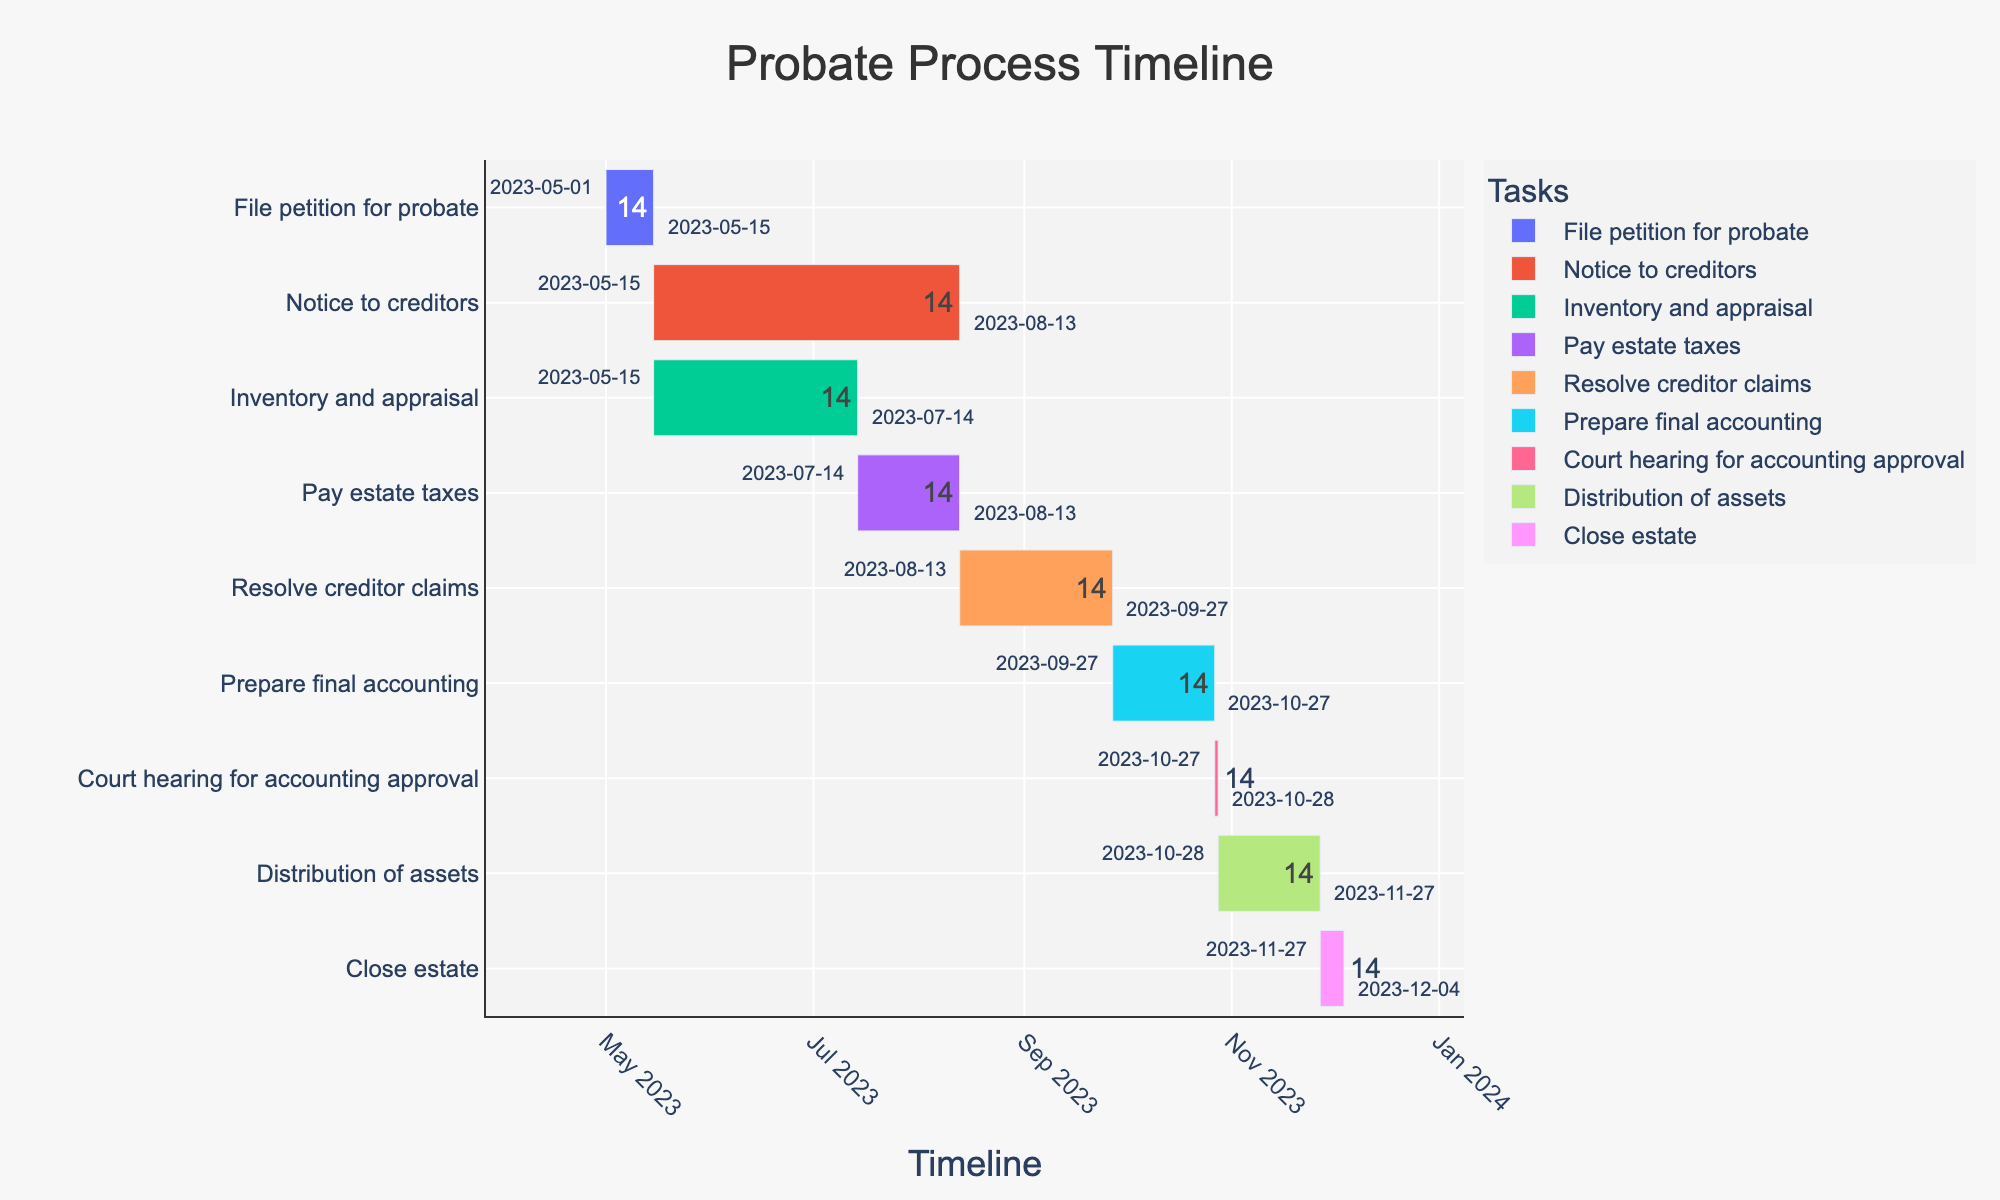How long does the "Notice to creditors" stage last? The "Notice to creditors" stage starts on 2023-05-15 and ends 90 days later, counting from the starting date, it lasts 90 days
Answer: 90 days Which stages overlap with the "Resolve creditor claims" stage? The "Resolve creditor claims" stage spans from 2023-08-13 to 2023-09-27. By looking at the timeline, it overlaps with the end of "Pay estate taxes" (2023-07-14 to 2023-08-13) and the duration of "Prepare final accounting" (2023-09-27 to 2023-10-27)
Answer: "Pay estate taxes" and "Prepare final accounting" How many stages take 30 days to complete? According to the timeline durations, stages "Pay estate taxes," "Prepare final accounting," and "Distribution of assets" each last 30 days
Answer: Three stages What's the earliest starting date for any task? The earliest task starts on 2023-05-01, which is for "File petition for probate"
Answer: 2023-05-01 How many days are there between the start of "File petition for probate" and the end of "Close estate"? "File petition for probate" starts on 2023-05-01 and "Close estate" ends on 2023-12-04. The days between these dates are calculated as the difference from 2023-05-01 to 2023-12-04
Answer: 217 days What's the duration of the longest stage? By comparing the durations, the longest stage is "Notice to creditors," with a duration of 90 days
Answer: 90 days Which stage has the shortest duration and what is it? The stage "Court hearing for accounting approval" has the shortest duration of 1 day
Answer: "Court hearing for accounting approval" and 1 day On what date does the "Distribution of assets" stage end? The "Distribution of assets" stage starts on 2023-10-28 and lasts for 30 days, so it ends on 2023-11-27
Answer: 2023-11-27 